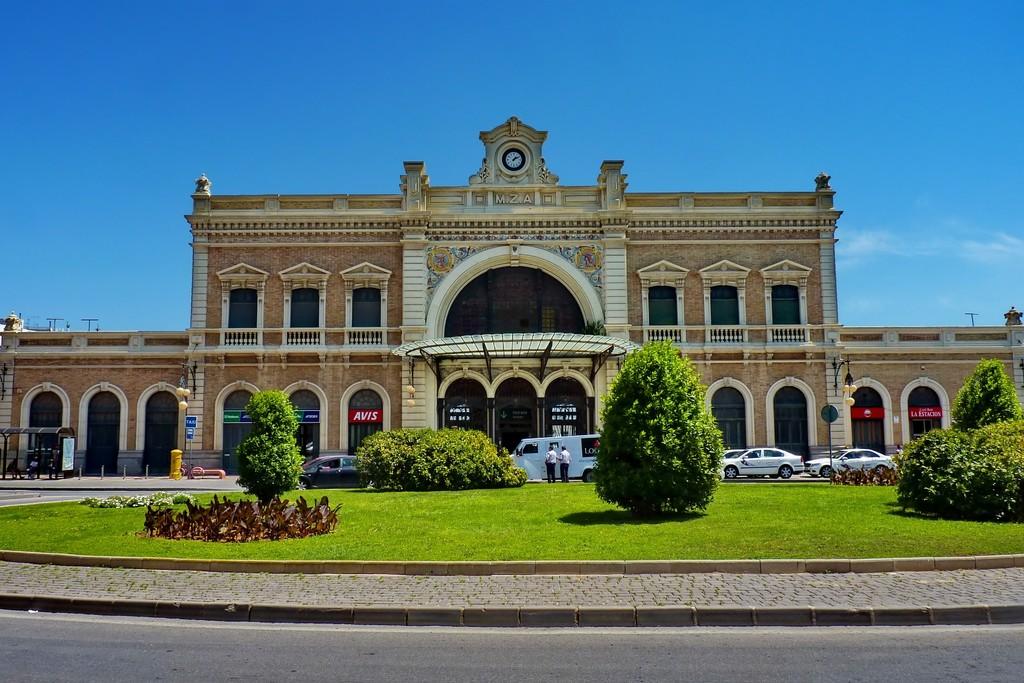What rental company is featured on the red banner on the left?
Offer a very short reply. Avis. What time is shown on the clock?
Keep it short and to the point. 1:10. 